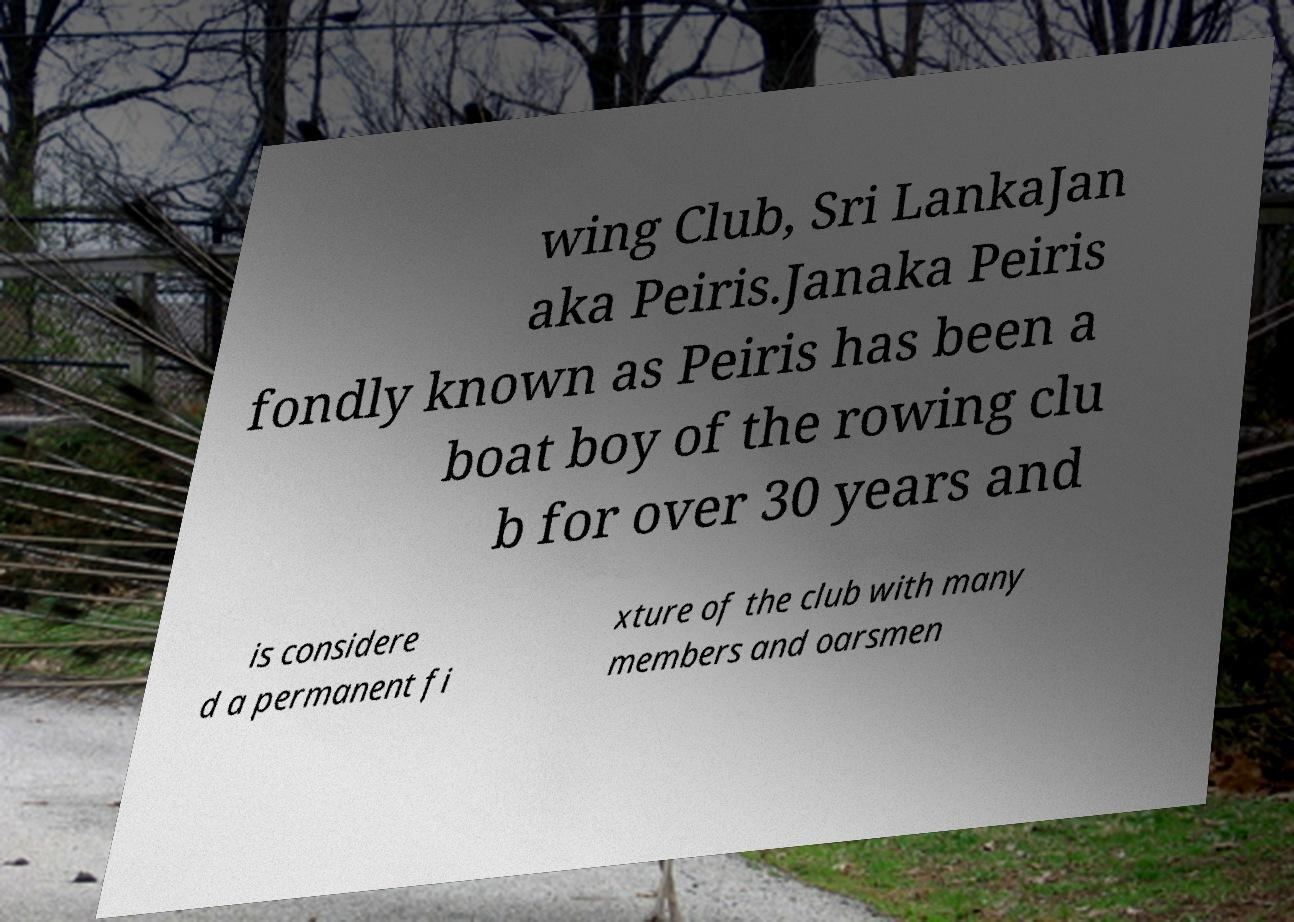Could you assist in decoding the text presented in this image and type it out clearly? wing Club, Sri LankaJan aka Peiris.Janaka Peiris fondly known as Peiris has been a boat boy of the rowing clu b for over 30 years and is considere d a permanent fi xture of the club with many members and oarsmen 